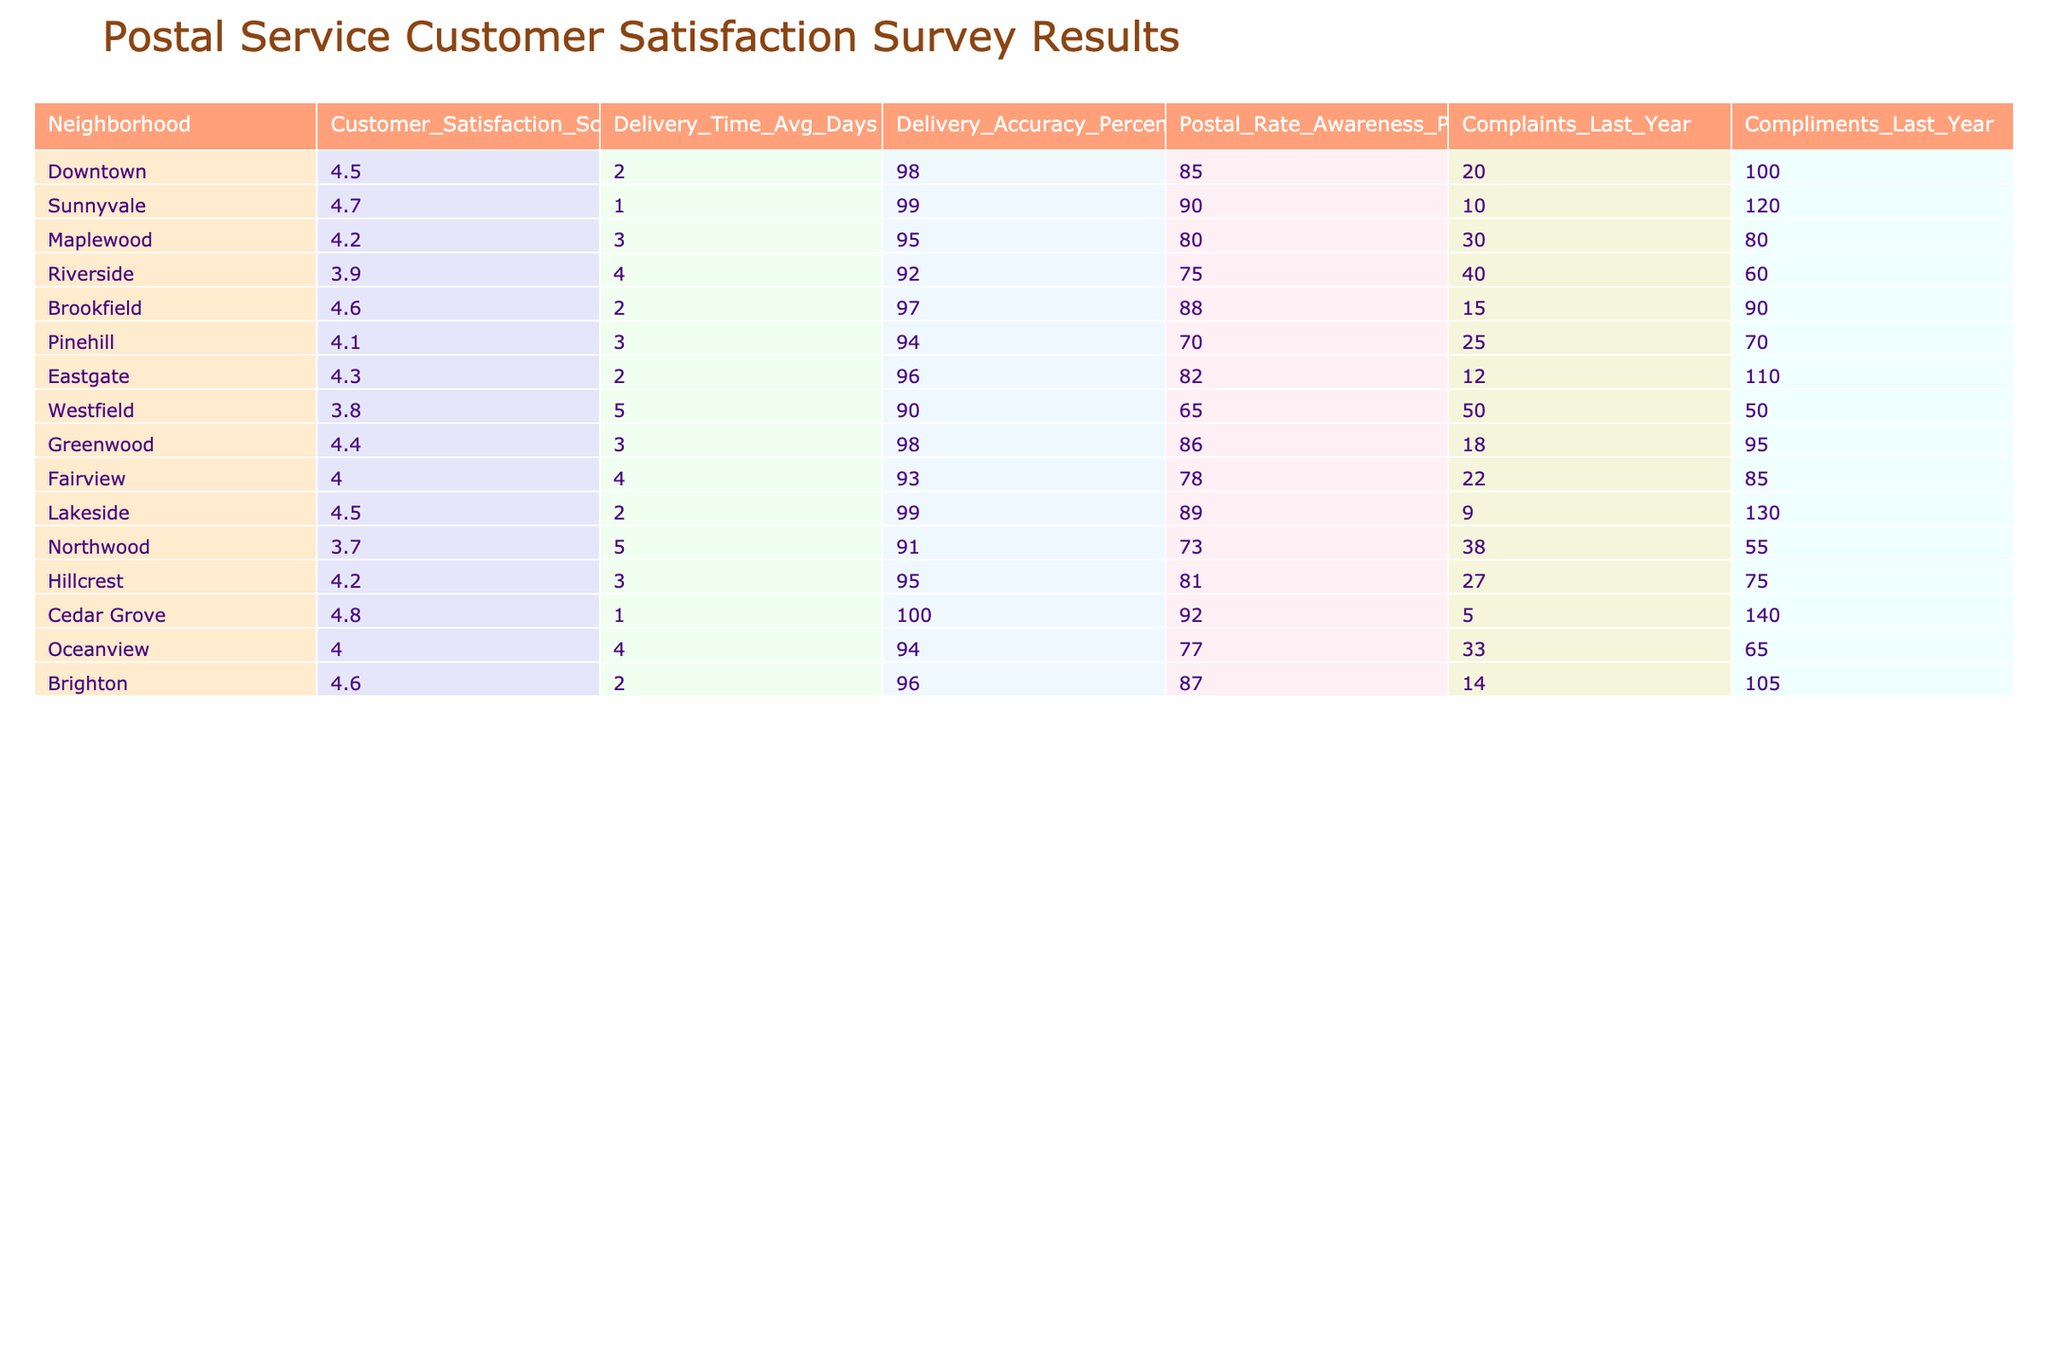What is the customer satisfaction score for Cedar Grove? The table lists Cedar Grove and shows its Customer Satisfaction Score as 4.8.
Answer: 4.8 Which neighborhood has the highest delivery accuracy percentage? Looking through the Delivery Accuracy Percentage column, Cedar Grove has 100%, which is the highest.
Answer: Cedar Grove What is the average number of complaints across all neighborhoods? To find the average complaints, add the complaints from each neighborhood (20 + 10 + 30 + 40 + 15 + 25 + 12 + 50 + 18 + 22 + 9 + 38 + 27 + 5 + 33 + 14 =  435) and divide by the number of neighborhoods (16). 435 / 16 = 27.1875, which rounds to 27 when considering whole numbers.
Answer: 27 Is the delivery time average for Westfield greater than 4 days? Yes, the Delivery Time Avg Days for Westfield is listed as 5, which is greater than 4.
Answer: Yes Which neighborhood has the lowest customer satisfaction score? By scanning the Customer Satisfaction Score column, Riverside has the lowest score at 3.9.
Answer: Riverside How many compliments did Lakeside receive last year? The table shows that Lakeside received 130 compliments last year.
Answer: 130 What is the difference between the delivery accuracy percentage of Sunnyvale and Maplewood? Sunnyvale has a delivery accuracy of 99%, and Maplewood has 95%. The difference is 99 - 95 = 4 percentage points.
Answer: 4 Which neighborhood has the worst balance of customer complaints and compliments based on the last year's data? To find this, we can compare the ratio of complaints to compliments for each neighborhood. For example, Riverside has 40 complaints and 60 compliments (ratio is 40:60 or 2:3). Upon checking others, Westfield has the highest complaints at 50 and only 50 compliments (ratio is 50:50). Thus, Westfield has the worst balance (equal but high complaints).
Answer: Westfield What neighborhood has the best combination of high customer satisfaction and low complaints? Sunnyvale has the highest customer satisfaction score of 4.7 and only 10 complaints, which indicates a good balance. Other neighborhoods have lower satisfaction or higher complaints.
Answer: Sunnyvale What is the total postal rate awareness percentage for all neighborhoods combined? The total postal rate awareness percentage can be calculated by summing the percentages (85 + 90 + 80 + 75 + 88 + 70 + 82 + 65 + 86 + 78 + 89 + 73 + 81 + 92 + 77 + 87 = 1357). However, we can also take the average (1357 / 16 = 84.8125), but if we're only summing: 1357.
Answer: 1357 